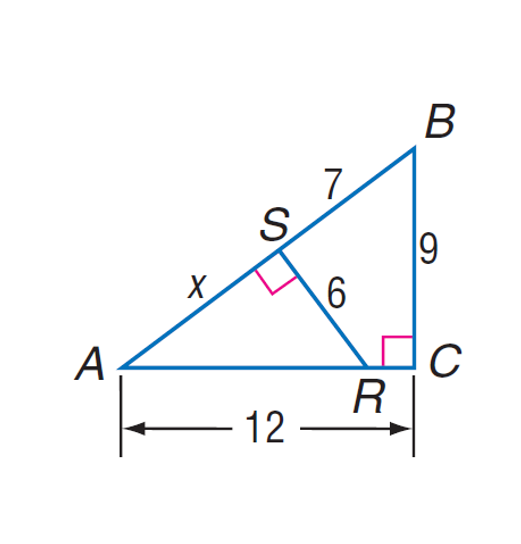Question: Find A S.
Choices:
A. 7
B. 7.8
C. 8
D. 9.2
Answer with the letter. Answer: C 